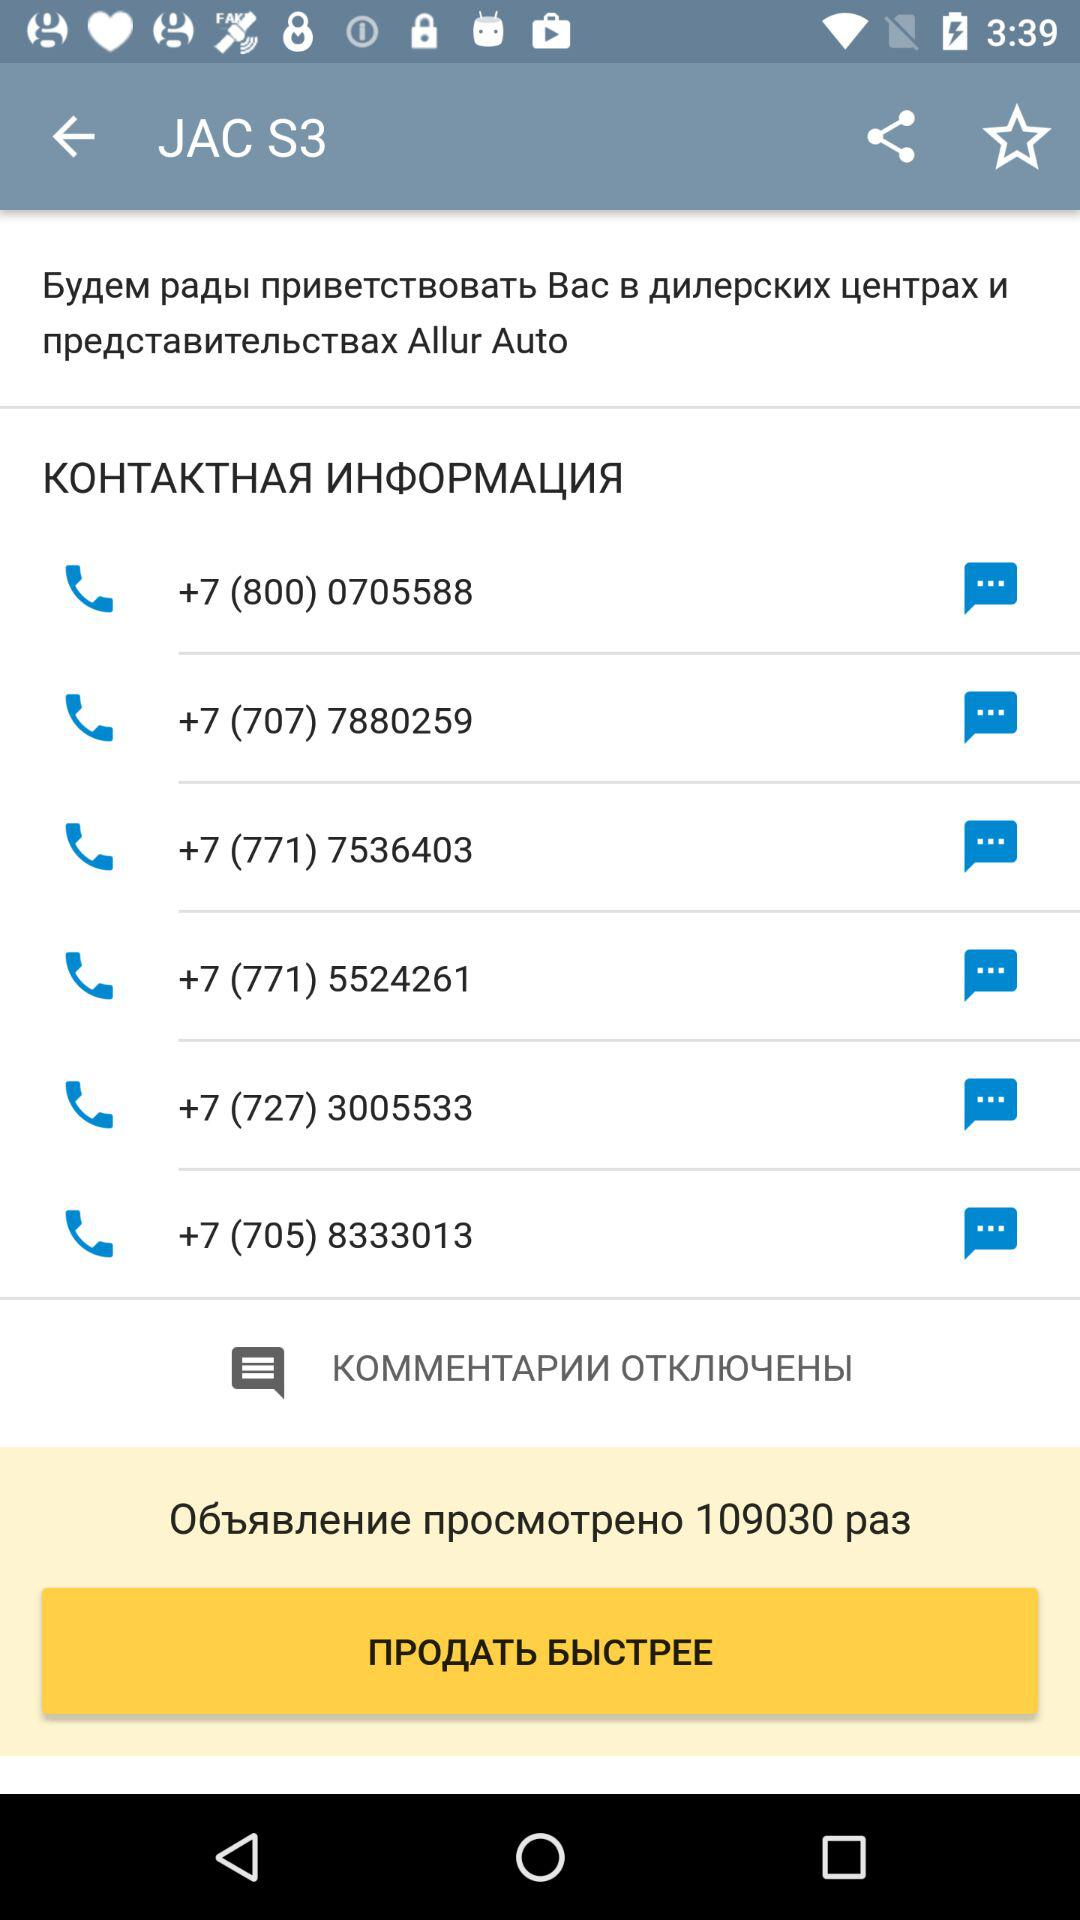How many contacts are there?
Answer the question using a single word or phrase. 6 